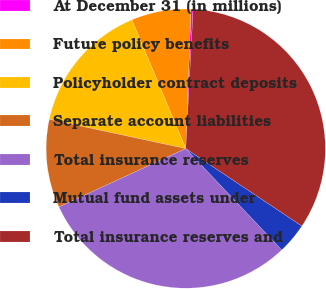Convert chart. <chart><loc_0><loc_0><loc_500><loc_500><pie_chart><fcel>At December 31 (in millions)<fcel>Future policy benefits<fcel>Policyholder contract deposits<fcel>Separate account liabilities<fcel>Total insurance reserves<fcel>Mutual fund assets under<fcel>Total insurance reserves and<nl><fcel>0.25%<fcel>6.9%<fcel>15.33%<fcel>10.23%<fcel>30.2%<fcel>3.57%<fcel>33.52%<nl></chart> 